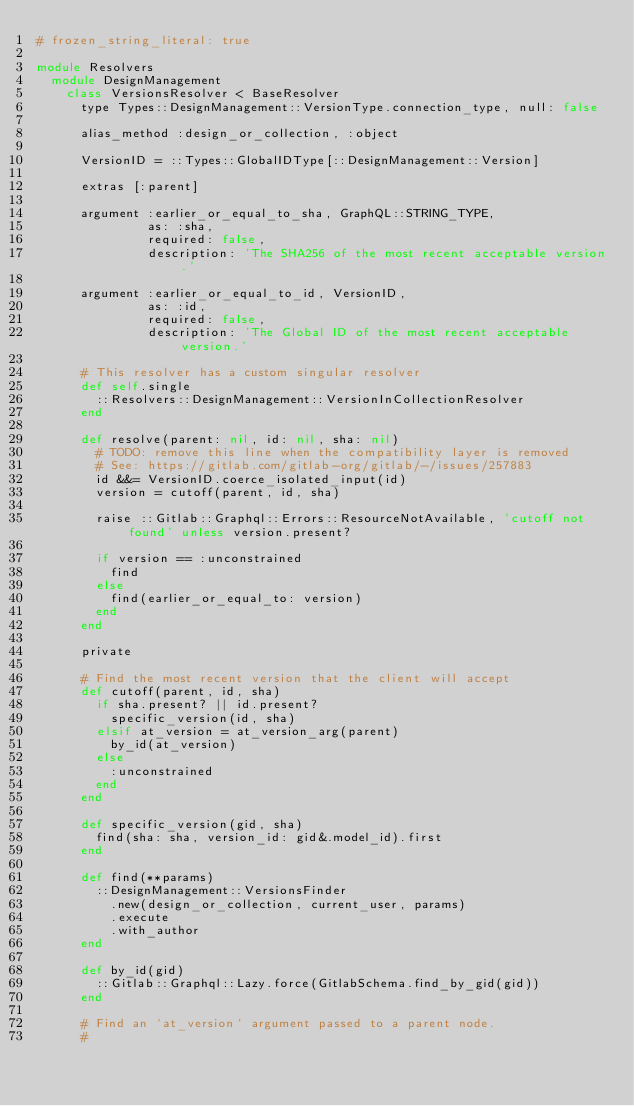<code> <loc_0><loc_0><loc_500><loc_500><_Ruby_># frozen_string_literal: true

module Resolvers
  module DesignManagement
    class VersionsResolver < BaseResolver
      type Types::DesignManagement::VersionType.connection_type, null: false

      alias_method :design_or_collection, :object

      VersionID = ::Types::GlobalIDType[::DesignManagement::Version]

      extras [:parent]

      argument :earlier_or_equal_to_sha, GraphQL::STRING_TYPE,
               as: :sha,
               required: false,
               description: 'The SHA256 of the most recent acceptable version.'

      argument :earlier_or_equal_to_id, VersionID,
               as: :id,
               required: false,
               description: 'The Global ID of the most recent acceptable version.'

      # This resolver has a custom singular resolver
      def self.single
        ::Resolvers::DesignManagement::VersionInCollectionResolver
      end

      def resolve(parent: nil, id: nil, sha: nil)
        # TODO: remove this line when the compatibility layer is removed
        # See: https://gitlab.com/gitlab-org/gitlab/-/issues/257883
        id &&= VersionID.coerce_isolated_input(id)
        version = cutoff(parent, id, sha)

        raise ::Gitlab::Graphql::Errors::ResourceNotAvailable, 'cutoff not found' unless version.present?

        if version == :unconstrained
          find
        else
          find(earlier_or_equal_to: version)
        end
      end

      private

      # Find the most recent version that the client will accept
      def cutoff(parent, id, sha)
        if sha.present? || id.present?
          specific_version(id, sha)
        elsif at_version = at_version_arg(parent)
          by_id(at_version)
        else
          :unconstrained
        end
      end

      def specific_version(gid, sha)
        find(sha: sha, version_id: gid&.model_id).first
      end

      def find(**params)
        ::DesignManagement::VersionsFinder
          .new(design_or_collection, current_user, params)
          .execute
          .with_author
      end

      def by_id(gid)
        ::Gitlab::Graphql::Lazy.force(GitlabSchema.find_by_gid(gid))
      end

      # Find an `at_version` argument passed to a parent node.
      #</code> 